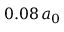<formula> <loc_0><loc_0><loc_500><loc_500>0 . 0 8 \, a _ { 0 }</formula> 